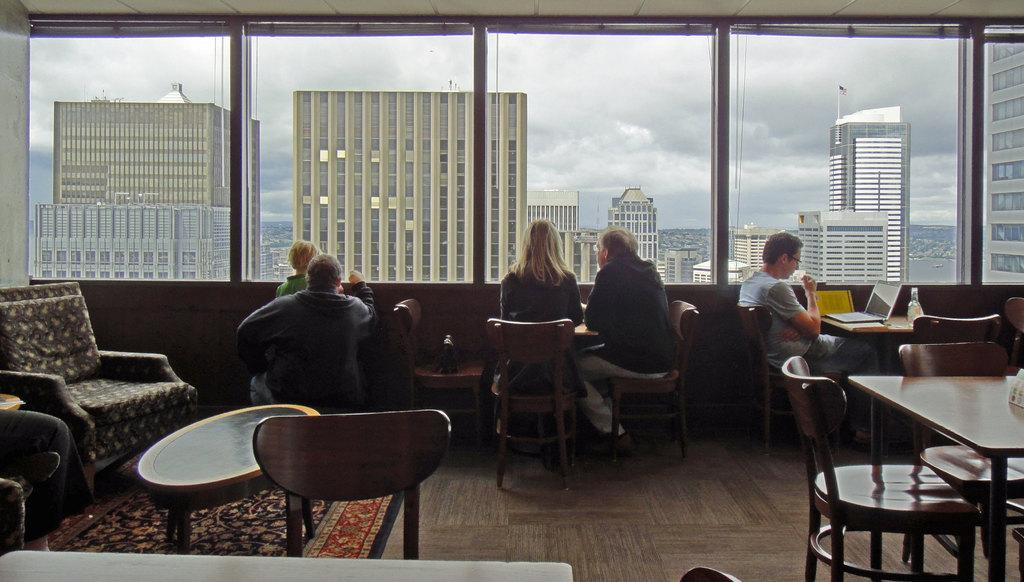Where was the image taken? The image was taken inside a room. What furniture is present in the room? There are tables and chairs in the room. What are the people in the image doing? People are sitting on chairs or tables. What can be seen outside the room through the windows? Buildings are visible in the image. What is visible at the top of the image? The sky is visible at the top of the image. What type of sugar is being served for breakfast in the image? There is no mention of sugar or breakfast in the image; it only shows people sitting on tables and chairs with buildings and the sky visible. 